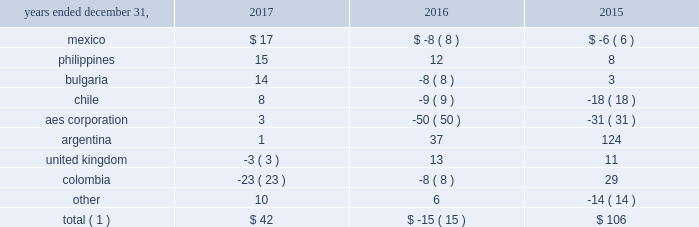Foreign currency transaction gains ( losses ) foreign currency transaction gains ( losses ) in millions were as follows: .
Total ( 1 ) $ 42 $ ( 15 ) $ 106 _____________________________ ( 1 ) includes gains of $ 21 million , $ 17 million and $ 247 million on foreign currency derivative contracts for the years ended december 31 , 2017 , 2016 and 2015 , respectively .
The company recognized net foreign currency transaction gains of $ 42 million for the year ended december 31 , 2017 primarily driven by transactions associated with vat activity in mexico , the amortization of frozen embedded derivatives in the philippines , and appreciation of the euro in bulgaria .
These gains were partially offset by unfavorable foreign currency derivatives in colombia .
The company recognized net foreign currency transaction losses of $ 15 million for the year ended december 31 , 2016 primarily due to remeasurement losses on intercompany notes , and losses on swaps and options at the aes corporation .
This loss was partially offset in argentina , mainly due to the favorable impact of foreign currency derivatives related to government receivables .
The company recognized net foreign currency transaction gains of $ 106 million for the year ended december 31 , 2015 primarily due to foreign currency derivatives related to government receivables in argentina and depreciation of the colombian peso in colombia .
These gains were partially offset due to decreases in the valuation of intercompany notes at the aes corporation and unfavorable devaluation of the chilean peso in chile .
Income tax expense income tax expense increased $ 958 million to $ 990 million in 2017 as compared to 2016 .
The company's effective tax rates were 128% ( 128 % ) and 17% ( 17 % ) for the years ended december 31 , 2017 and 2016 , respectively .
The net increase in the 2017 effective tax rate was due primarily to expense related to the u.s .
Tax reform one-time transition tax and remeasurement of deferred tax assets .
Further , the 2016 rate was impacted by the items described below .
Income tax expense decreased $ 380 million to $ 32 million in 2016 as compared to 2015 .
The company's effective tax rates were 17% ( 17 % ) and 42% ( 42 % ) for the years ended december 31 , 2016 and 2015 , respectively .
The net decrease in the 2016 effective tax rate was due , in part , to the 2016 asset impairments in the u.s. , as well as the devaluation of the peso in certain of our mexican subsidiaries and the release of valuation allowance at certain of our brazilian subsidiaries .
These favorable items were partially offset by the unfavorable impact of chilean income tax law reform enacted during the first quarter of 2016 .
Further , the 2015 rate was due , in part , to the nondeductible 2015 impairment of goodwill at dp&l and chilean withholding taxes offset by the release of valuation allowance at certain of our businesses in brazil , vietnam and the u.s .
See note 19 2014asset impairment expense included in item 8 . 2014financial statements and supplementary data of this form 10-k for additional information regarding the 2016 u.s .
Asset impairments .
See note 20 2014income taxes included in item 8 . 2014financial statements and supplementary data of this form 10-k for additional information regarding the 2016 chilean income tax law reform .
Our effective tax rate reflects the tax effect of significant operations outside the u.s. , which are generally taxed at rates different than the u.s .
Statutory rate .
Foreign earnings may be taxed at rates higher than the new u.s .
Corporate rate of 21% ( 21 % ) and a greater portion of our foreign earnings may be subject to current u.s .
Taxation under the new tax rules .
A future proportionate change in the composition of income before income taxes from foreign and domestic tax jurisdictions could impact our periodic effective tax rate .
The company also benefits from reduced tax rates in certain countries as a result of satisfying specific commitments regarding employment and capital investment .
See note 20 2014income taxes included in item 8 . 2014financial statements and supplementary data of this form 10-k for additional information regarding these reduced rates. .
In 2017 what percentage of foreign currency transaction gains were attributable to philippines? 
Computations: (15 / 42)
Answer: 0.35714. 